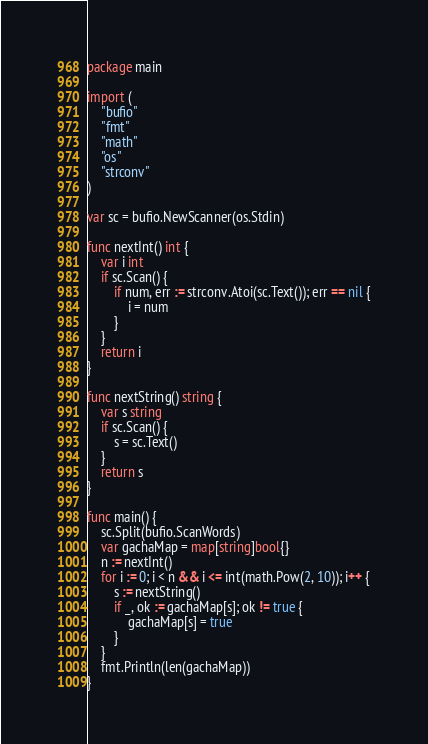Convert code to text. <code><loc_0><loc_0><loc_500><loc_500><_Go_>package main

import (
	"bufio"
	"fmt"
	"math"
	"os"
	"strconv"
)

var sc = bufio.NewScanner(os.Stdin)

func nextInt() int {
	var i int
	if sc.Scan() {
		if num, err := strconv.Atoi(sc.Text()); err == nil {
			i = num
		}
	}
	return i
}

func nextString() string {
	var s string
	if sc.Scan() {
		s = sc.Text()
	}
	return s
}

func main() {
	sc.Split(bufio.ScanWords)
	var gachaMap = map[string]bool{}
	n := nextInt()
	for i := 0; i < n && i <= int(math.Pow(2, 10)); i++ {
		s := nextString()
		if _, ok := gachaMap[s]; ok != true {
			gachaMap[s] = true
		}
	}
	fmt.Println(len(gachaMap))
}
</code> 